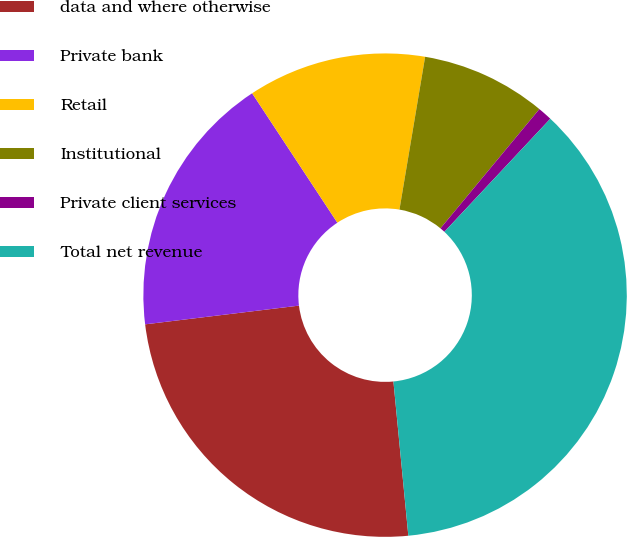<chart> <loc_0><loc_0><loc_500><loc_500><pie_chart><fcel>data and where otherwise<fcel>Private bank<fcel>Retail<fcel>Institutional<fcel>Private client services<fcel>Total net revenue<nl><fcel>24.61%<fcel>17.66%<fcel>11.92%<fcel>8.37%<fcel>0.96%<fcel>36.49%<nl></chart> 